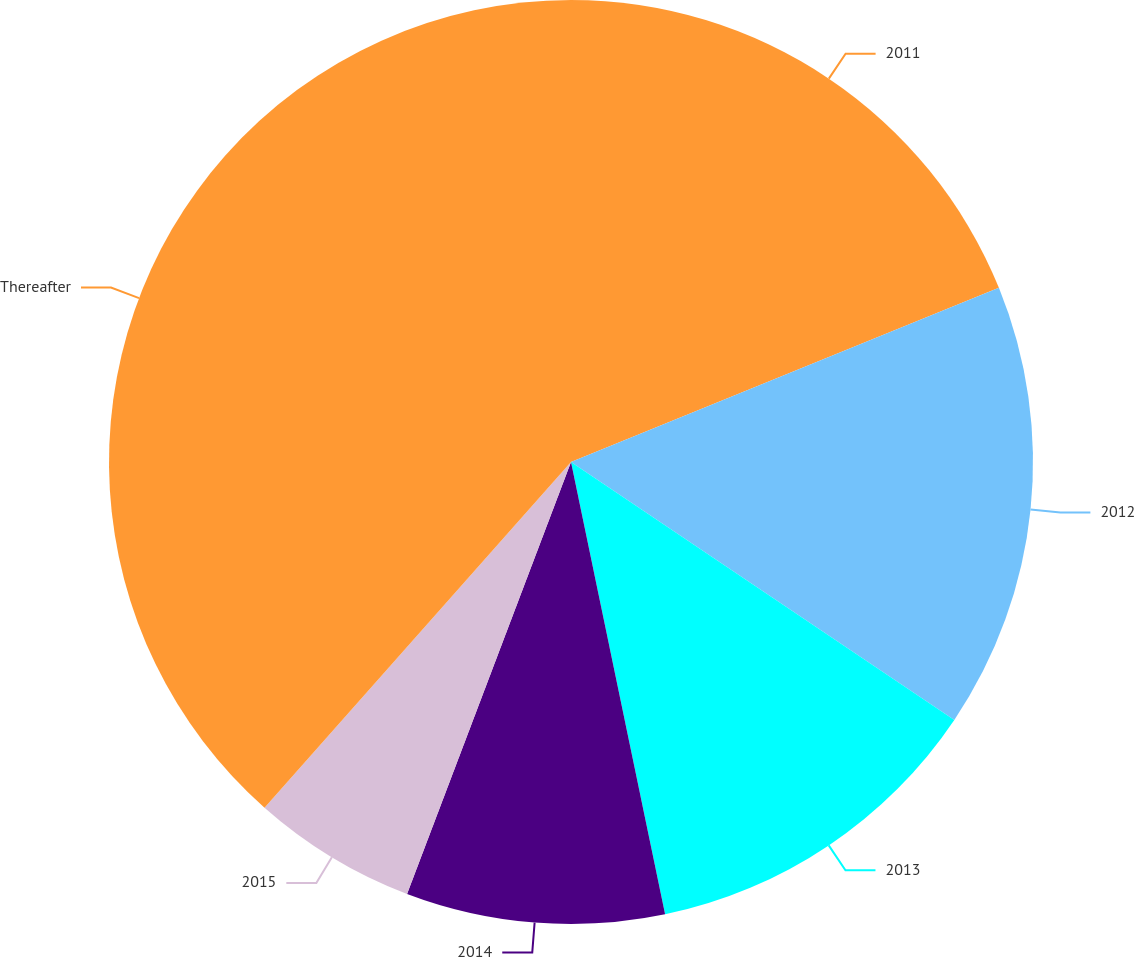Convert chart. <chart><loc_0><loc_0><loc_500><loc_500><pie_chart><fcel>2011<fcel>2012<fcel>2013<fcel>2014<fcel>2015<fcel>Thereafter<nl><fcel>18.85%<fcel>15.58%<fcel>12.31%<fcel>9.04%<fcel>5.77%<fcel>38.46%<nl></chart> 